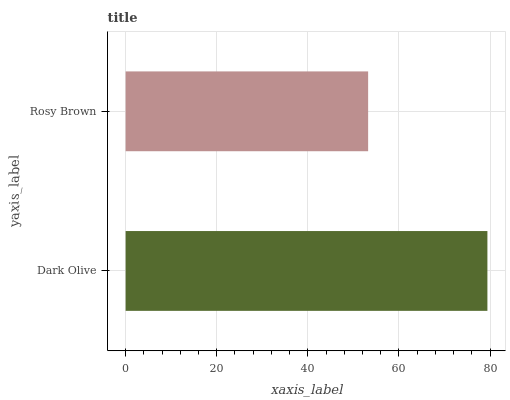Is Rosy Brown the minimum?
Answer yes or no. Yes. Is Dark Olive the maximum?
Answer yes or no. Yes. Is Rosy Brown the maximum?
Answer yes or no. No. Is Dark Olive greater than Rosy Brown?
Answer yes or no. Yes. Is Rosy Brown less than Dark Olive?
Answer yes or no. Yes. Is Rosy Brown greater than Dark Olive?
Answer yes or no. No. Is Dark Olive less than Rosy Brown?
Answer yes or no. No. Is Dark Olive the high median?
Answer yes or no. Yes. Is Rosy Brown the low median?
Answer yes or no. Yes. Is Rosy Brown the high median?
Answer yes or no. No. Is Dark Olive the low median?
Answer yes or no. No. 